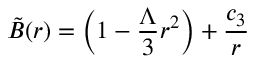<formula> <loc_0><loc_0><loc_500><loc_500>\tilde { B } ( r ) = \left ( 1 - \frac { \Lambda } { 3 } r ^ { 2 } \right ) + \frac { c _ { 3 } } { r }</formula> 